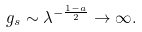Convert formula to latex. <formula><loc_0><loc_0><loc_500><loc_500>g _ { s } \sim \lambda ^ { - \frac { 1 - a } { 2 } } \to \infty .</formula> 